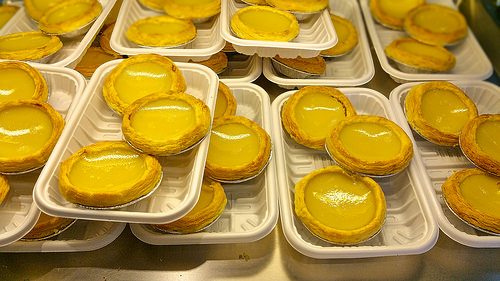<image>
Can you confirm if the egg tart is on the container? Yes. Looking at the image, I can see the egg tart is positioned on top of the container, with the container providing support. 